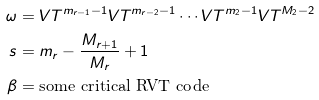<formula> <loc_0><loc_0><loc_500><loc_500>\omega & = V T ^ { m _ { r - 1 } - 1 } V T ^ { m _ { r - 2 } - 1 } \cdots V T ^ { m _ { 2 } - 1 } V T ^ { M _ { 2 } - 2 } \\ s & = m _ { r } - \frac { M _ { r + 1 } } { M _ { r } } + 1 \\ \beta & = \text {some critical RVT code}</formula> 